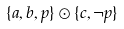<formula> <loc_0><loc_0><loc_500><loc_500>\{ a , b , p \} \odot \{ c , \neg p \}</formula> 